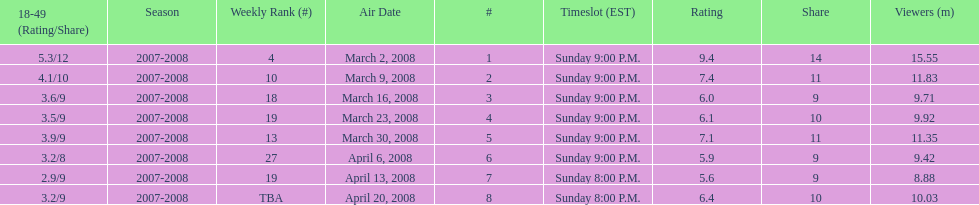How many shows had more than 10 million viewers? 4. 